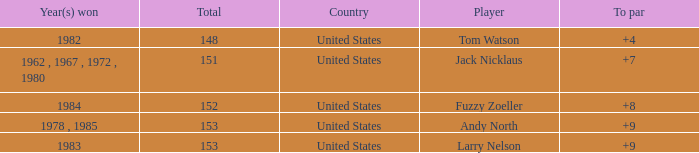What is the To par of Player Andy North with a Total larger than 153? 0.0. 